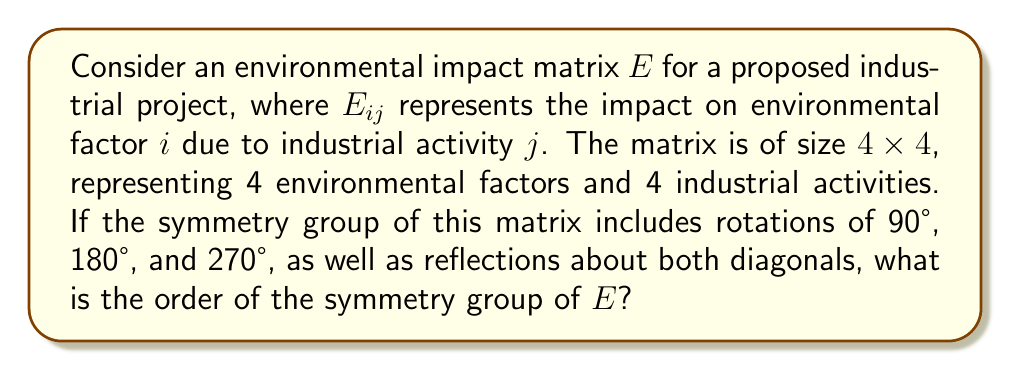Provide a solution to this math problem. To solve this problem, we need to analyze the symmetry group of the given environmental impact matrix. Let's approach this step-by-step:

1) First, let's identify the symmetries described:
   - Rotations: 90°, 180°, 270° (and implicitly 360° or 0°, which is the identity)
   - Reflections: about both diagonals

2) These symmetries correspond to the symmetry group of a square, which is known as the dihedral group $D_4$.

3) To find the order of this group, we need to count the number of distinct symmetry operations:

   a) Rotations:
      - 0° (identity)
      - 90°
      - 180°
      - 270°
   
   b) Reflections:
      - About the main diagonal
      - About the secondary diagonal
      - About the vertical axis
      - About the horizontal axis

4) Counting these symmetries, we get:
   $$\text{Number of symmetries} = 4 \text{ (rotations)} + 4 \text{ (reflections)} = 8$$

5) Therefore, the order of the symmetry group is 8.

This means that there are 8 ways to transform the environmental impact matrix while preserving its structure, which could be significant for policy makers in understanding the interdependencies and symmetries in environmental impacts across different industrial activities.
Answer: The order of the symmetry group of the environmental impact matrix $E$ is 8. 